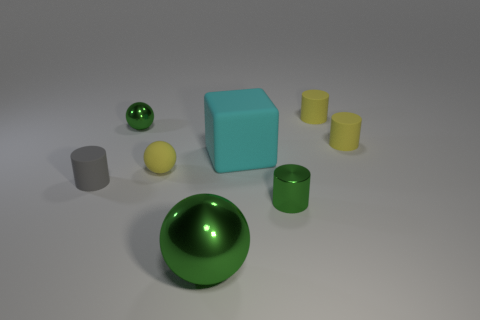Subtract all matte cylinders. How many cylinders are left? 1 Add 1 big cyan cubes. How many objects exist? 9 Subtract all green spheres. How many spheres are left? 1 Subtract 1 cylinders. How many cylinders are left? 3 Subtract all spheres. How many objects are left? 5 Subtract all blue blocks. Subtract all tiny shiny cylinders. How many objects are left? 7 Add 8 gray rubber objects. How many gray rubber objects are left? 9 Add 6 cubes. How many cubes exist? 7 Subtract 0 brown blocks. How many objects are left? 8 Subtract all green cylinders. Subtract all blue balls. How many cylinders are left? 3 